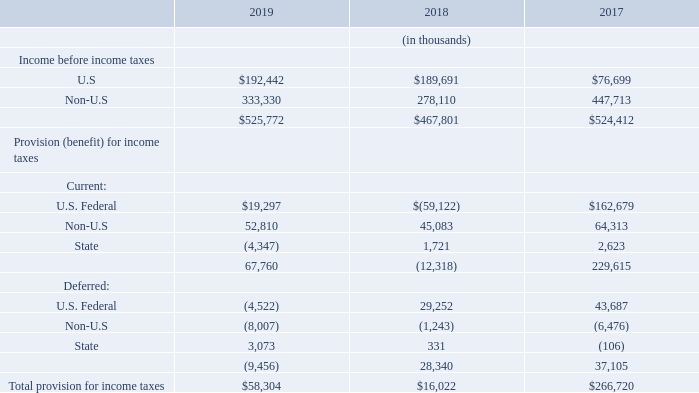S. INCOME TAXES
The components of income (loss) before income taxes and the provision (benefit) for income taxes as shown in the consolidated statements of operations were as follows:
Income tax expense for 2019, 2018 and 2017 totaled $58.3 million, $16.0 million and $266.7 million, respectively. The effective tax rate for 2019, 2018 and 2017 was 11.1%, 3.4% and 50.9%, respectively.
On December 22, 2017, the U.S. enacted the Tax Cuts and Jobs Act of 2017 (the “Tax Reform Act”), making significant changes to the Internal Revenue Code. The Tax Reform Act has significant direct and indirect implications for accounting for income taxes under ASC 740, “Accounting for Income Taxes” some of which could not be calculated with precision until further clarification and guidance was made available from tax authorities, regulatory bodies or the FASB. In light of this uncertainty, on December 22, 2017 the SEC issued Staff Accounting Bulletin (“SAB”) No. 118, “Income Tax Accounting Implications of the Tax Cuts and Jobs Act,” to address uncertainty in the application of U.S. GAAP when the registrant does not have the necessary information available, prepared, or analyzed (including computations) in reasonable detail to complete the accounting for certain income tax effects of the Tax Reform Act. In accordance with SAB 118, Teradyne recorded $186.0 million of additional income tax expense in the fourth quarter of 2017 which represented Teradyne’s best estimate of the impact of the Tax Reform Act in accordance with Teradyne’s understanding of the Tax Reform Act and available guidance as of that date. The $186.0 million was primarily composed of expense of $161.0 million related to the one-time transition tax on the mandatory deemed repatriation of foreign earnings, $33.6 million of expense related to the remeasurement of certain deferred tax assets and liabilities based on the rates at which they are expected to reverse in the future, and a benefit of $10.3 million associated with the impact of correlative adjustments on uncertain tax positions. In accordance with the requirements of SAB 118, in the fourth quarter of 2018, Teradyne completed its analysis of the effect of the Tax Reform Act based on the application of the most recently available guidance as of December 31, 2018 and recorded $49.5 million of net income tax benefit. The net benefit consisted of $51.7 million of benefit resulting from a reduction in the estimate of the one-time transition tax on the mandatory deemed repatriation of foreign earnings and an expense of $2.2 million associated with the impact of correlative adjustments on uncertain tax positions.
What are the types of provision (benefit) for income taxes? Current, deferred. What are the components under Current provision (benefit) for income taxes? U.s. federal, non-u.s, state. What does the table show? The components of income (loss) before income taxes and the provision (benefit) for income taxes as shown in the consolidated statements of operations. Which year was the amount of income before taxes the largest? 525,772>524,412>467,801
Answer: 2019. What was the change in U.S. Income before income taxes in 2019 from 2018?
Answer scale should be: thousand. 192,442-189,691
Answer: 2751. What was the percentage change in U.S. Income before income taxes in 2019 from 2018?
Answer scale should be: percent. (192,442-189,691)/189,691
Answer: 1.45. 